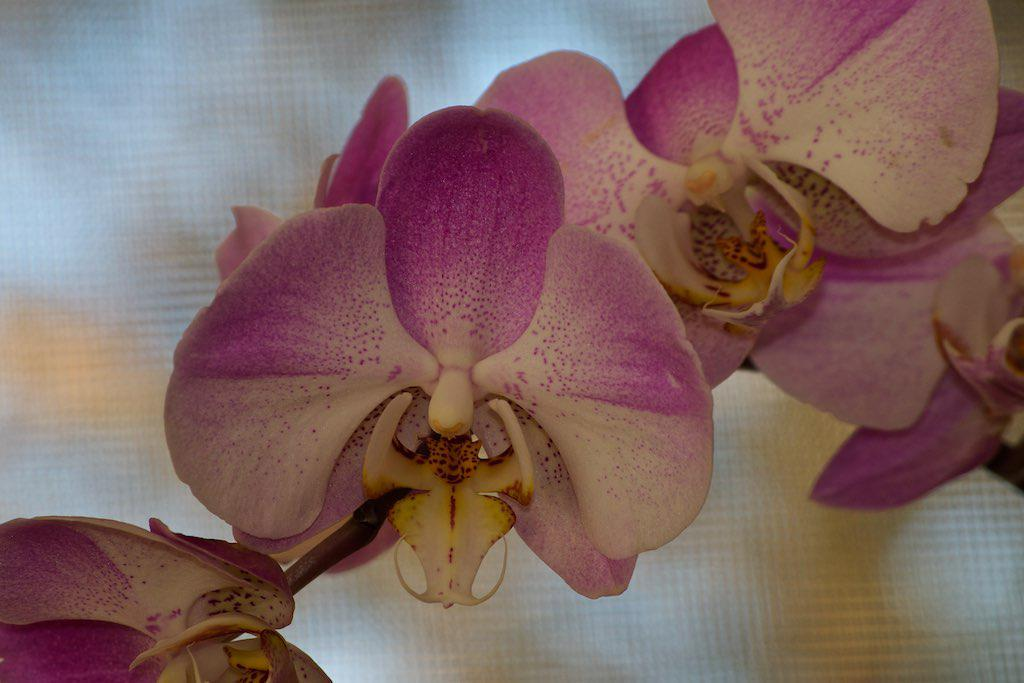What is present in the image that has a stem? There is a stem in the image. What is attached to the stem? The stem has flowers. What is the color of the flowers? The flowers are pink in color. Are there any other colors present on the flowers? Some parts of the flowers are white. How many copies of the flower can be seen in the image? There is only one flower in the image, so it cannot be copied within the image. 